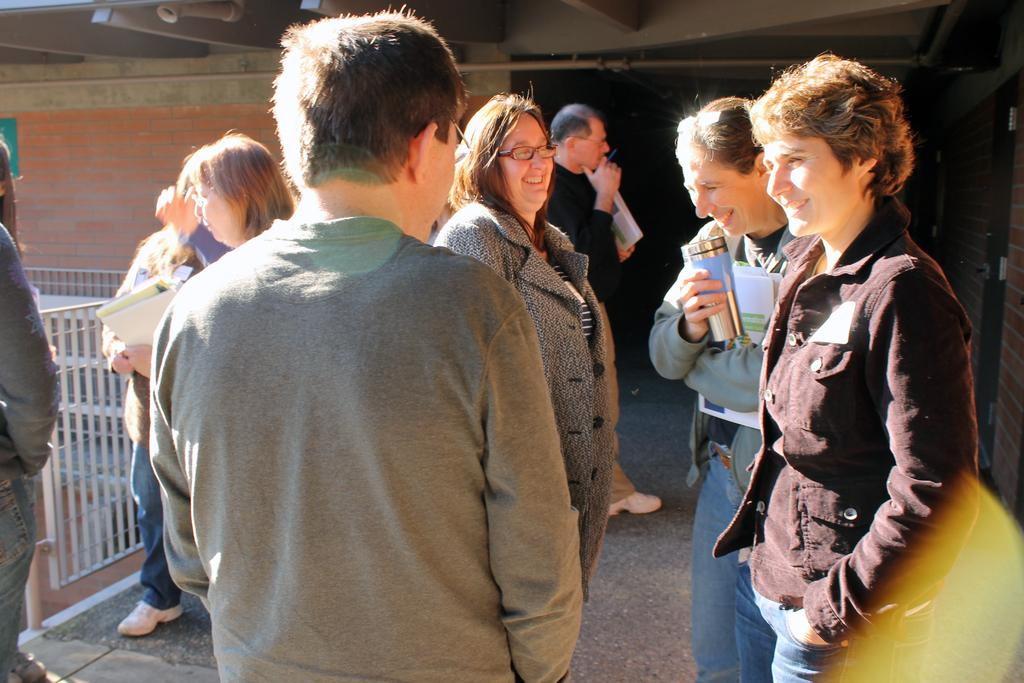What can be seen in the image? There are people standing in the image. What is visible in the background of the image? There is a wall, an entrance, and fencing in the background of the image. What time of day is it in the image, and how does the nerve affect the people's behavior? The provided facts do not mention the time of day or any nerves affecting the people's behavior. The image only shows people standing with a wall, entrance, and fencing in the background. 